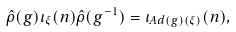<formula> <loc_0><loc_0><loc_500><loc_500>\hat { \rho } ( g ) \iota _ { \xi } ( n ) \hat { \rho } ( g ^ { - 1 } ) = \iota _ { A d ( g ) ( \xi ) } ( n ) ,</formula> 